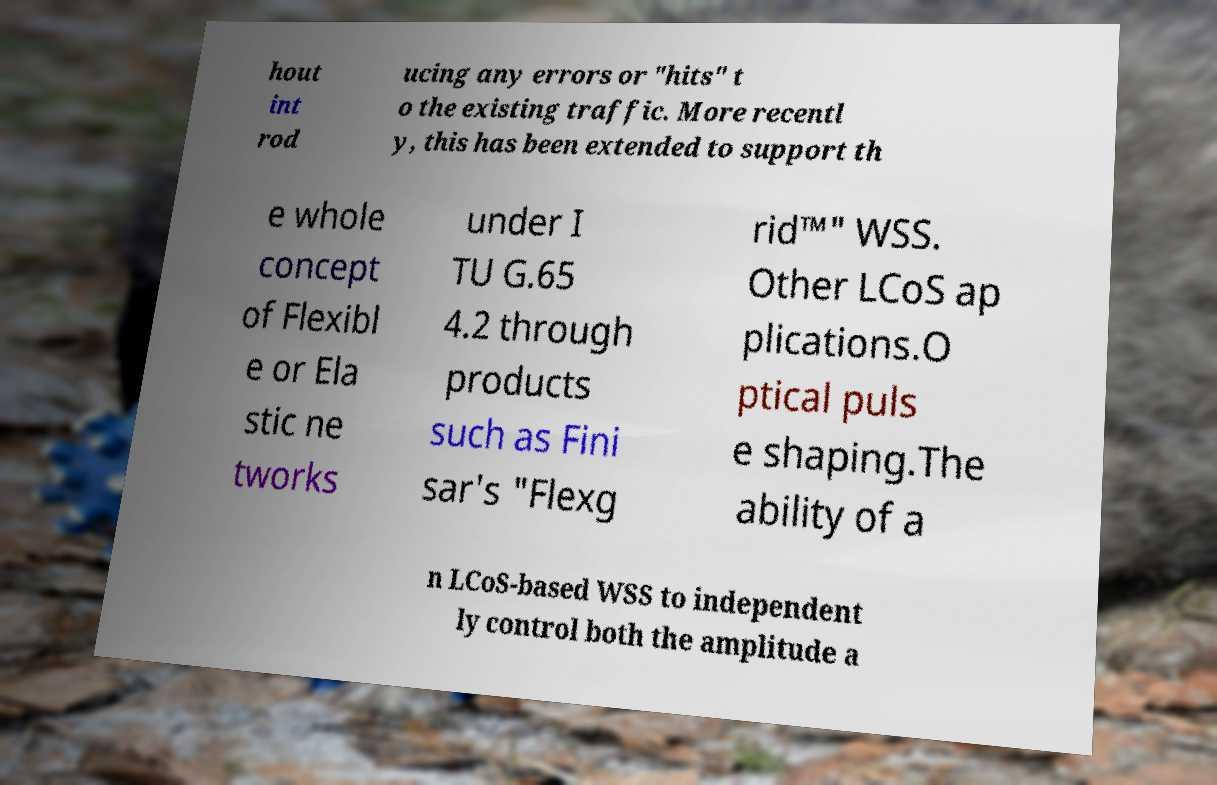I need the written content from this picture converted into text. Can you do that? hout int rod ucing any errors or "hits" t o the existing traffic. More recentl y, this has been extended to support th e whole concept of Flexibl e or Ela stic ne tworks under I TU G.65 4.2 through products such as Fini sar's "Flexg rid™" WSS. Other LCoS ap plications.O ptical puls e shaping.The ability of a n LCoS-based WSS to independent ly control both the amplitude a 